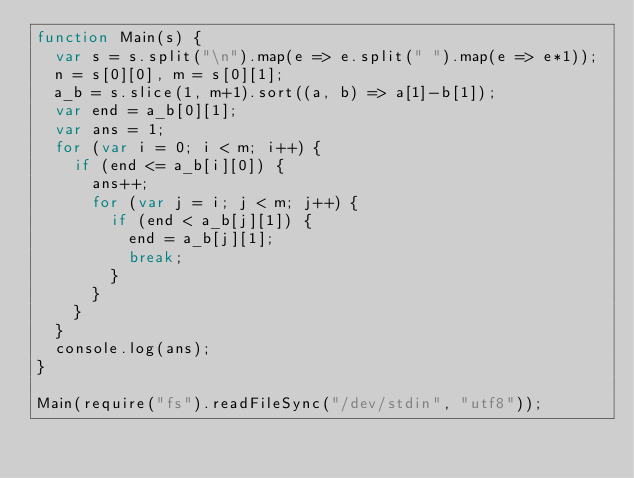<code> <loc_0><loc_0><loc_500><loc_500><_JavaScript_>function Main(s) {
  var s = s.split("\n").map(e => e.split(" ").map(e => e*1));
  n = s[0][0], m = s[0][1];
  a_b = s.slice(1, m+1).sort((a, b) => a[1]-b[1]);
  var end = a_b[0][1];
  var ans = 1;
  for (var i = 0; i < m; i++) {
    if (end <= a_b[i][0]) {
      ans++;
      for (var j = i; j < m; j++) {
        if (end < a_b[j][1]) {
          end = a_b[j][1];
          break;
        }
      }
    }
  }
  console.log(ans);
}

Main(require("fs").readFileSync("/dev/stdin", "utf8"));</code> 